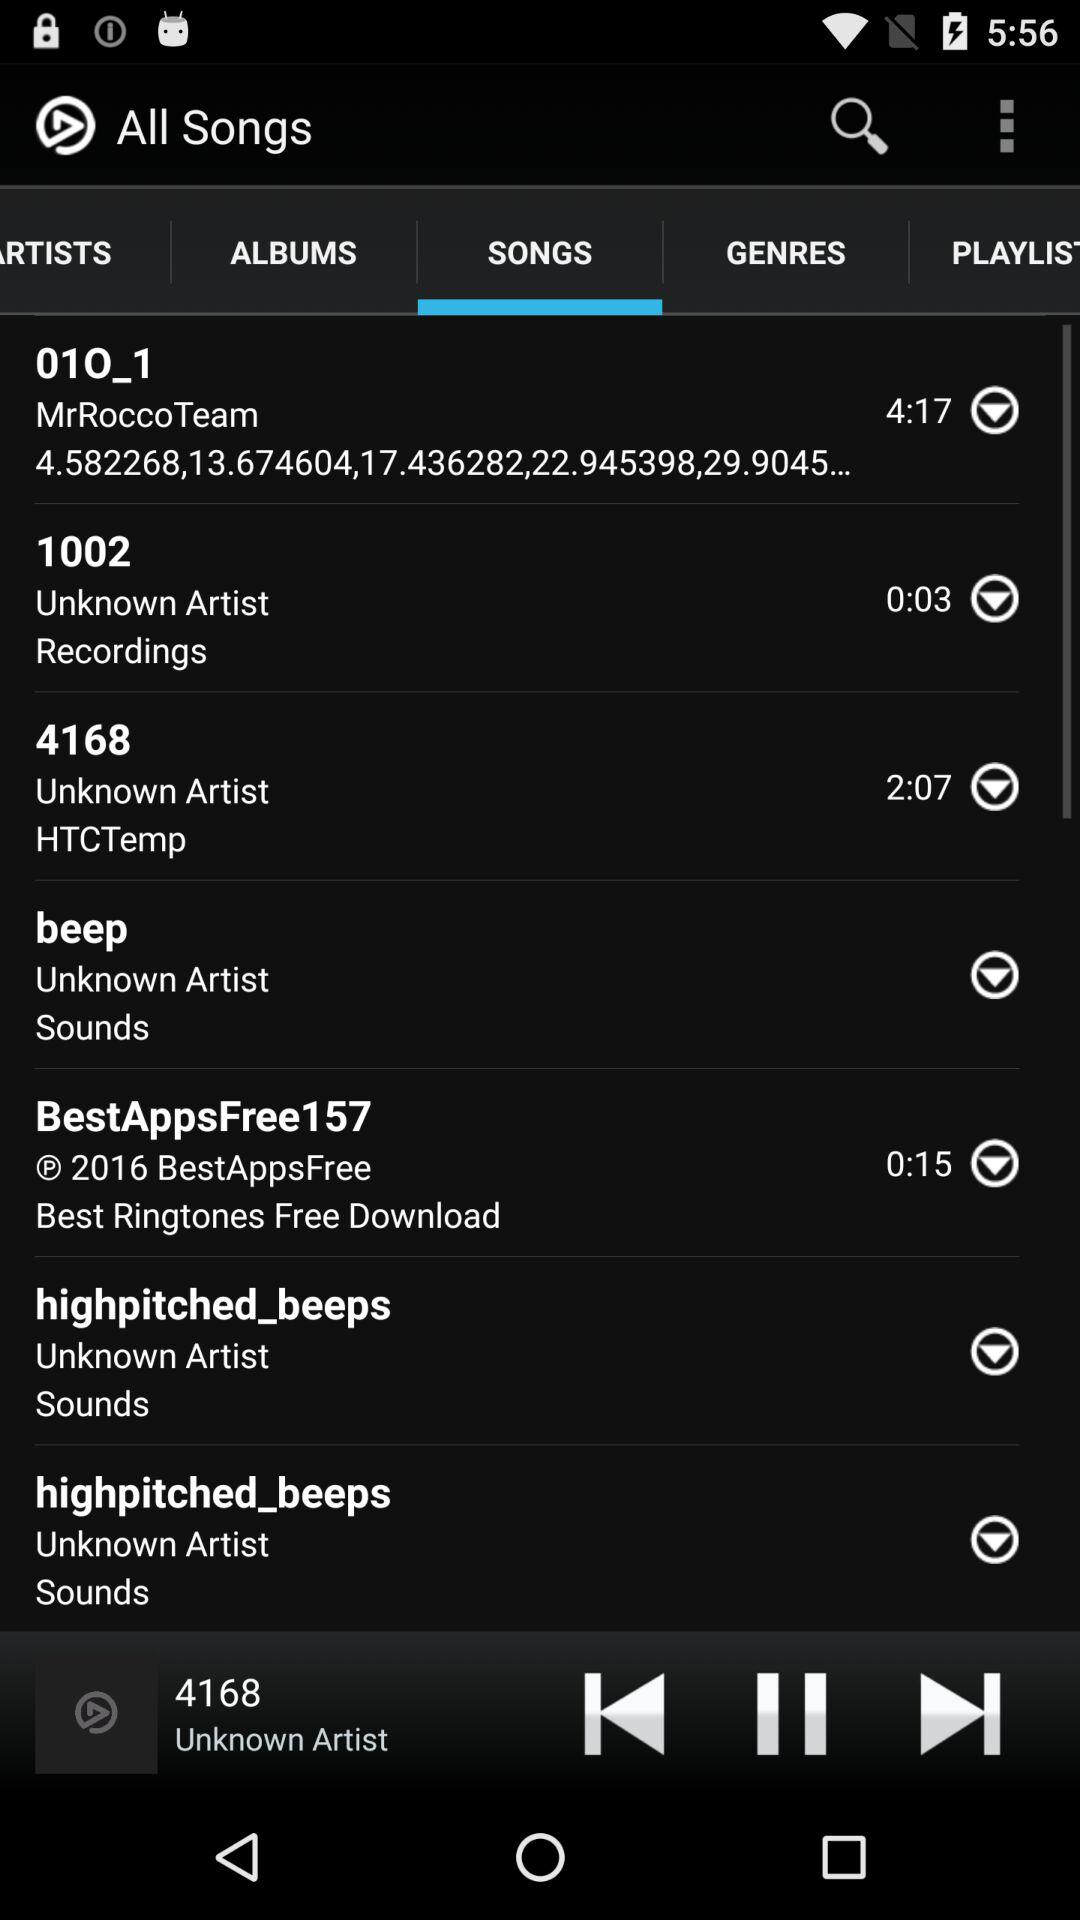Which song is playing? The song is "4168". 